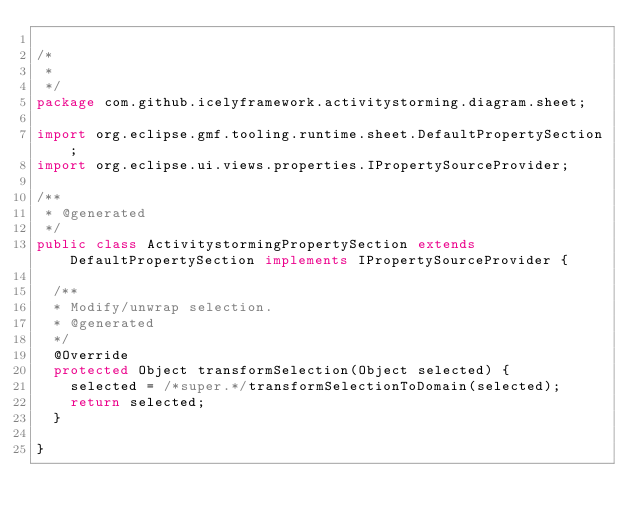Convert code to text. <code><loc_0><loc_0><loc_500><loc_500><_Java_>
/*
 * 
 */
package com.github.icelyframework.activitystorming.diagram.sheet;

import org.eclipse.gmf.tooling.runtime.sheet.DefaultPropertySection;
import org.eclipse.ui.views.properties.IPropertySourceProvider;

/**
 * @generated
 */
public class ActivitystormingPropertySection extends DefaultPropertySection implements IPropertySourceProvider {

	/**
	* Modify/unwrap selection.
	* @generated
	*/
	@Override
	protected Object transformSelection(Object selected) {
		selected = /*super.*/transformSelectionToDomain(selected);
		return selected;
	}

}
</code> 